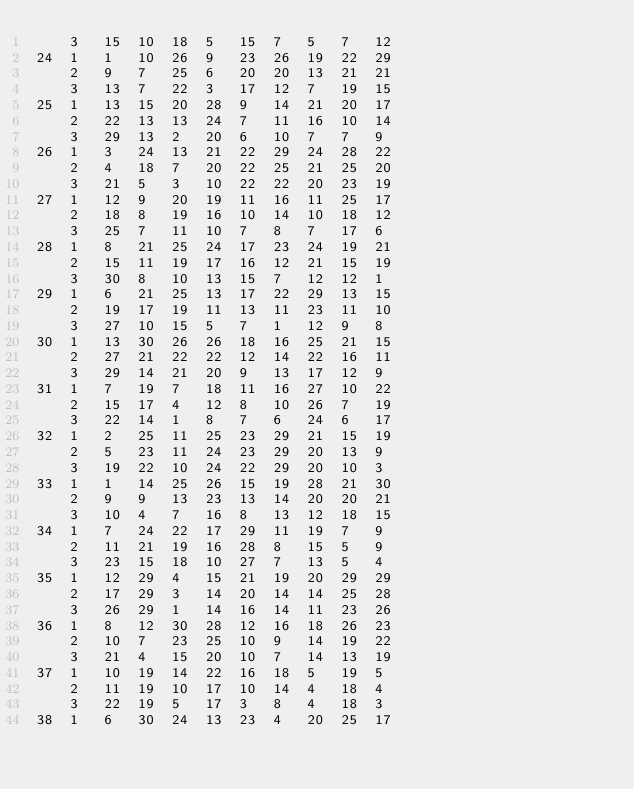Convert code to text. <code><loc_0><loc_0><loc_500><loc_500><_ObjectiveC_>	3	15	10	18	5	15	7	5	7	12	
24	1	1	10	26	9	23	26	19	22	29	
	2	9	7	25	6	20	20	13	21	21	
	3	13	7	22	3	17	12	7	19	15	
25	1	13	15	20	28	9	14	21	20	17	
	2	22	13	13	24	7	11	16	10	14	
	3	29	13	2	20	6	10	7	7	9	
26	1	3	24	13	21	22	29	24	28	22	
	2	4	18	7	20	22	25	21	25	20	
	3	21	5	3	10	22	22	20	23	19	
27	1	12	9	20	19	11	16	11	25	17	
	2	18	8	19	16	10	14	10	18	12	
	3	25	7	11	10	7	8	7	17	6	
28	1	8	21	25	24	17	23	24	19	21	
	2	15	11	19	17	16	12	21	15	19	
	3	30	8	10	13	15	7	12	12	1	
29	1	6	21	25	13	17	22	29	13	15	
	2	19	17	19	11	13	11	23	11	10	
	3	27	10	15	5	7	1	12	9	8	
30	1	13	30	26	26	18	16	25	21	15	
	2	27	21	22	22	12	14	22	16	11	
	3	29	14	21	20	9	13	17	12	9	
31	1	7	19	7	18	11	16	27	10	22	
	2	15	17	4	12	8	10	26	7	19	
	3	22	14	1	8	7	6	24	6	17	
32	1	2	25	11	25	23	29	21	15	19	
	2	5	23	11	24	23	29	20	13	9	
	3	19	22	10	24	22	29	20	10	3	
33	1	1	14	25	26	15	19	28	21	30	
	2	9	9	13	23	13	14	20	20	21	
	3	10	4	7	16	8	13	12	18	15	
34	1	7	24	22	17	29	11	19	7	9	
	2	11	21	19	16	28	8	15	5	9	
	3	23	15	18	10	27	7	13	5	4	
35	1	12	29	4	15	21	19	20	29	29	
	2	17	29	3	14	20	14	14	25	28	
	3	26	29	1	14	16	14	11	23	26	
36	1	8	12	30	28	12	16	18	26	23	
	2	10	7	23	25	10	9	14	19	22	
	3	21	4	15	20	10	7	14	13	19	
37	1	10	19	14	22	16	18	5	19	5	
	2	11	19	10	17	10	14	4	18	4	
	3	22	19	5	17	3	8	4	18	3	
38	1	6	30	24	13	23	4	20	25	17	</code> 